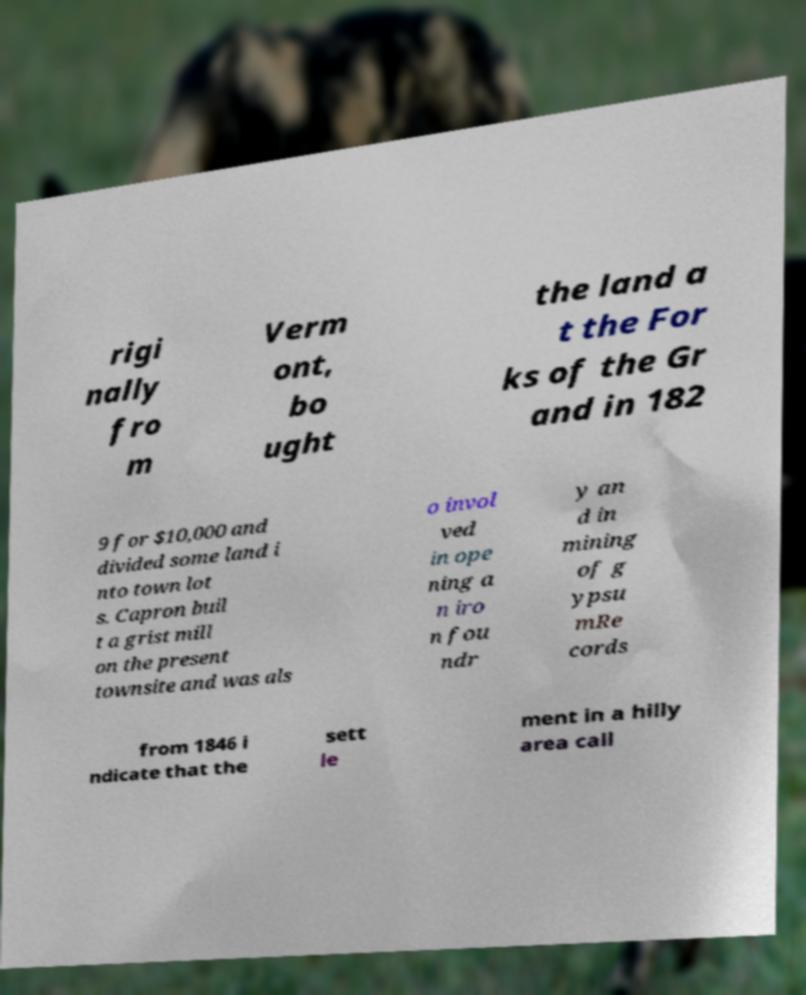Can you read and provide the text displayed in the image?This photo seems to have some interesting text. Can you extract and type it out for me? rigi nally fro m Verm ont, bo ught the land a t the For ks of the Gr and in 182 9 for $10,000 and divided some land i nto town lot s. Capron buil t a grist mill on the present townsite and was als o invol ved in ope ning a n iro n fou ndr y an d in mining of g ypsu mRe cords from 1846 i ndicate that the sett le ment in a hilly area call 